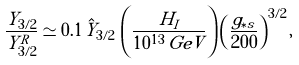Convert formula to latex. <formula><loc_0><loc_0><loc_500><loc_500>\frac { Y _ { 3 / 2 } } { Y _ { 3 / 2 } ^ { R } } \simeq 0 . 1 \, \hat { Y } _ { 3 / 2 } \, \left ( \frac { H _ { I } } { 1 0 ^ { 1 3 } \, G e V } \right ) \left ( \frac { g _ { \ast s } } { 2 0 0 } \right ) ^ { 3 / 2 } ,</formula> 